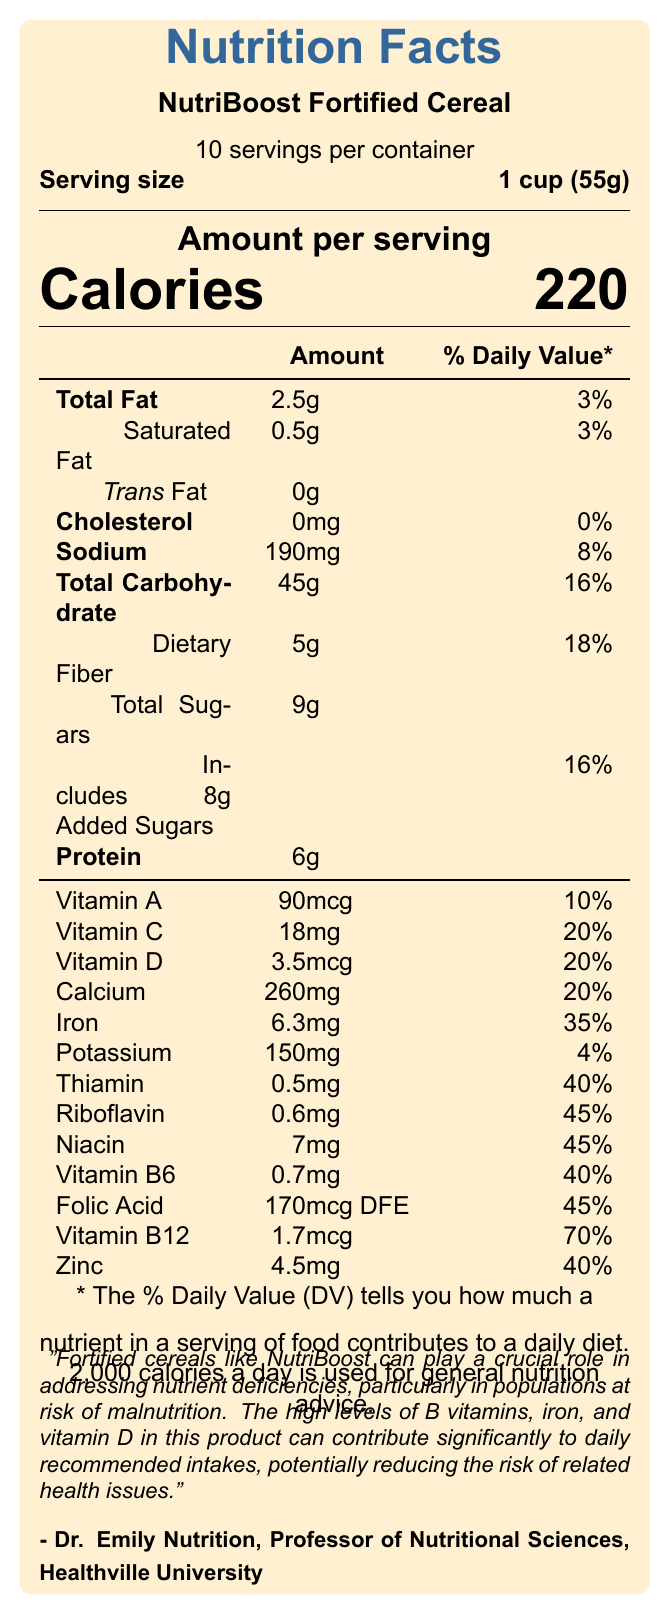What is the serving size of NutriBoost Fortified Cereal? The document states that the serving size of NutriBoost Fortified Cereal is 1 cup, which is equivalent to 55 grams.
Answer: 1 cup (55g) How many servings are there per container? The document mentions that there are 10 servings per container.
Answer: 10 What is the calorie count per serving of NutriBoost Fortified Cereal? The document lists that each serving contains 220 calories.
Answer: 220 calories What percentage of the daily value of iron does one serving provide? The document specifies that one serving provides 35% of the daily value for iron.
Answer: 35% How much protein is in one serving? The document indicates that there are 6 grams of protein per serving.
Answer: 6g How many grams of total carbohydrate does one serving contain? The document shows that one serving contains 45 grams of total carbohydrate.
Answer: 45g What percentage of daily value of Vitamin D is provided per serving? The document states that each serving provides 20% of the daily value for Vitamin D.
Answer: 20% Which nutrient has the highest percentage of daily value per serving? A. Iron B. Vitamin B12 C. Thiamin D. Calcium The document indicates that one serving provides 70% of the daily value for Vitamin B12, which is the highest percentage among the listed nutrients.
Answer: B. Vitamin B12 How much added sugars does one serving include? A. 7g B. 8g C. 9g D. 10g The document specifies that one serving includes 8 grams of added sugars.
Answer: B. 8g Is there any cholesterol in NutriBoost Fortified Cereal? (Yes/No) The document states that the cholesterol content is 0mg, indicating there is no cholesterol.
Answer: No Summarize the main idea of the document. The document contains a detailed nutrition facts label for NutriBoost Fortified Cereal, indicating its impact on daily nutrient intake, including calories, fats, carbohydrates, proteins, vitamins, and minerals. It emphasizes the cereal's role in addressing nutrient deficiencies, citing insights from Dr. Emily Nutrition on the value of fortified cereals in public health.
Answer: NutriBoost Fortified Cereal provides a detailed nutrition facts label, showcasing its contributions to daily recommended nutrient intake. It highlights the presence of various essential vitamins and minerals, significant for public health nutrition. How much potassium does one serving of NutriBoost Fortified Cereal contain? The document lists that one serving contains 150mg of potassium.
Answer: 150mg What does Dr. Emily Nutrition say about fortified cereals like NutriBoost? The document quotes Dr. Emily Nutrition stating that fortified cereals can help address nutrient deficiencies and significantly contribute to daily recommended nutrient intakes, potentially reducing related health issues.
Answer: They can address nutrient deficiencies and contribute to daily recommended intakes, reducing health risks. Can the exact process of fortification be determined from the document? The document does not provide details about the specific process of fortification used in producing NutriBoost Fortified Cereal.
Answer: Not enough information What is the total fat content per serving, and how does it compare to daily value percentages? The document states that each serving contains 2.5 grams of total fat, which is 3% of the daily value.
Answer: 2.5g, 3% of daily value 